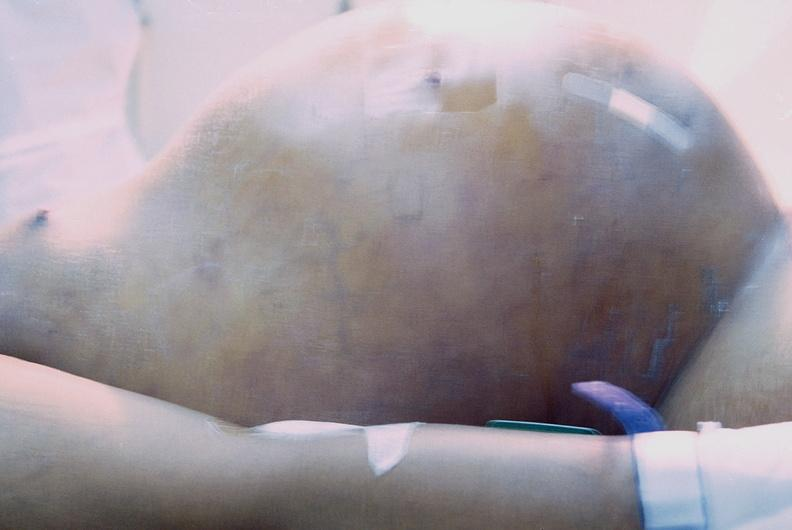does this image show ascites?
Answer the question using a single word or phrase. Yes 